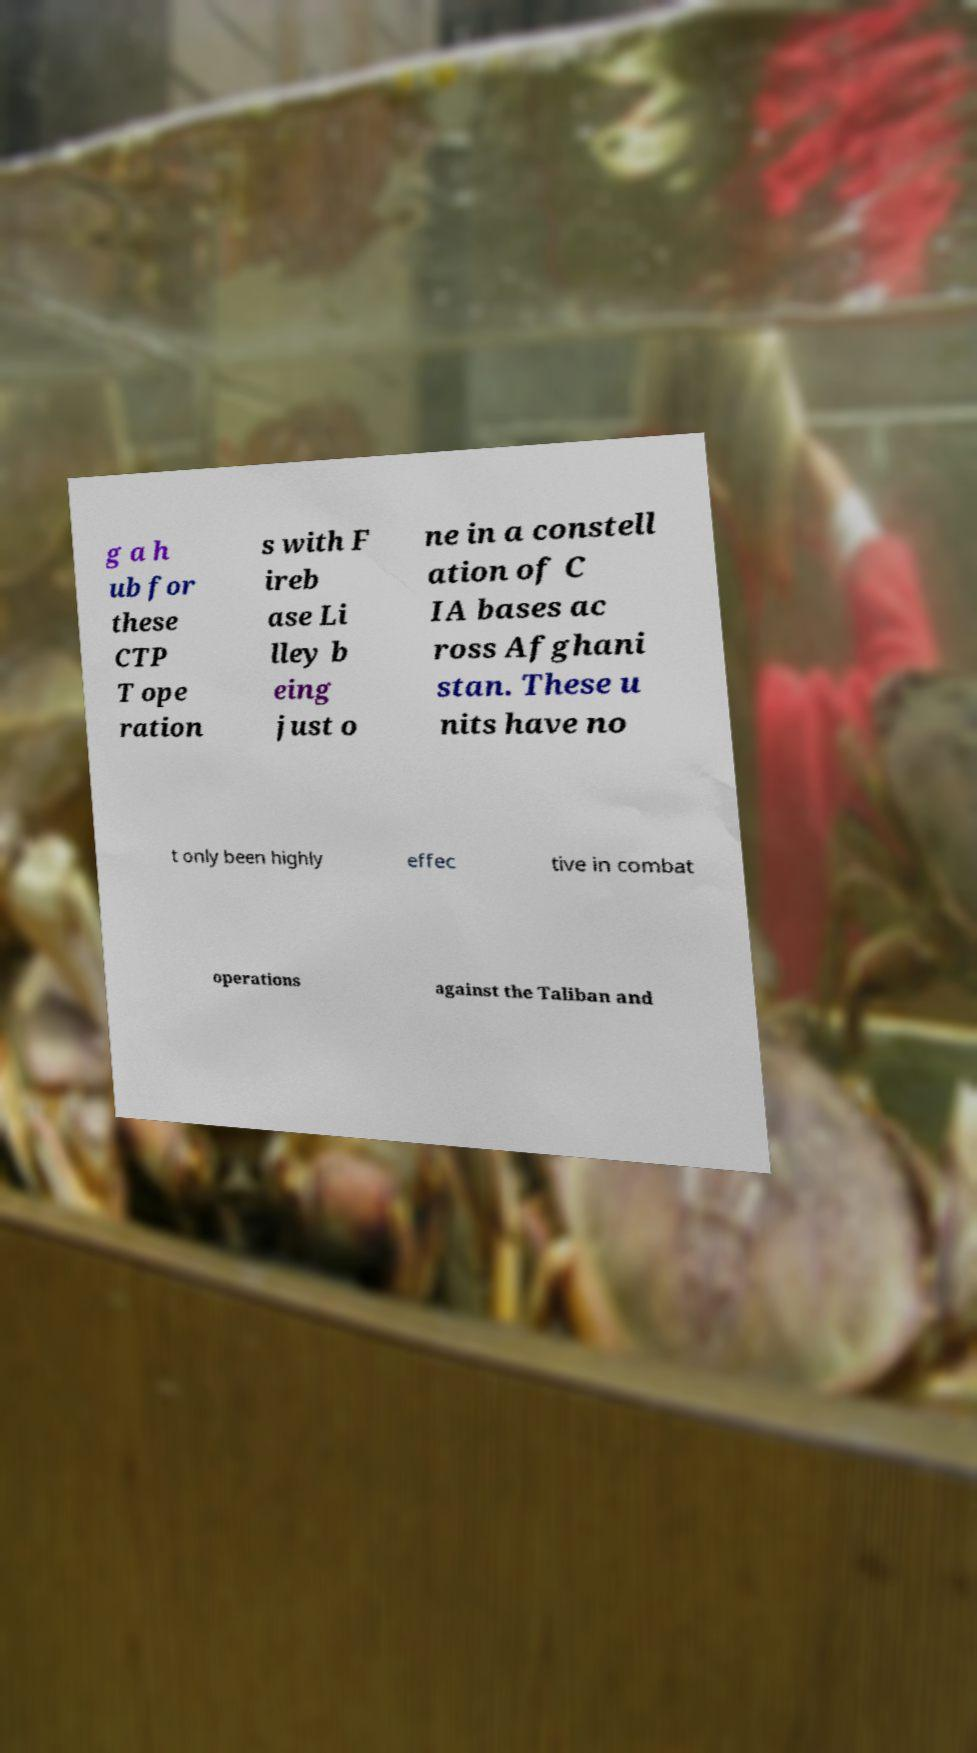I need the written content from this picture converted into text. Can you do that? g a h ub for these CTP T ope ration s with F ireb ase Li lley b eing just o ne in a constell ation of C IA bases ac ross Afghani stan. These u nits have no t only been highly effec tive in combat operations against the Taliban and 